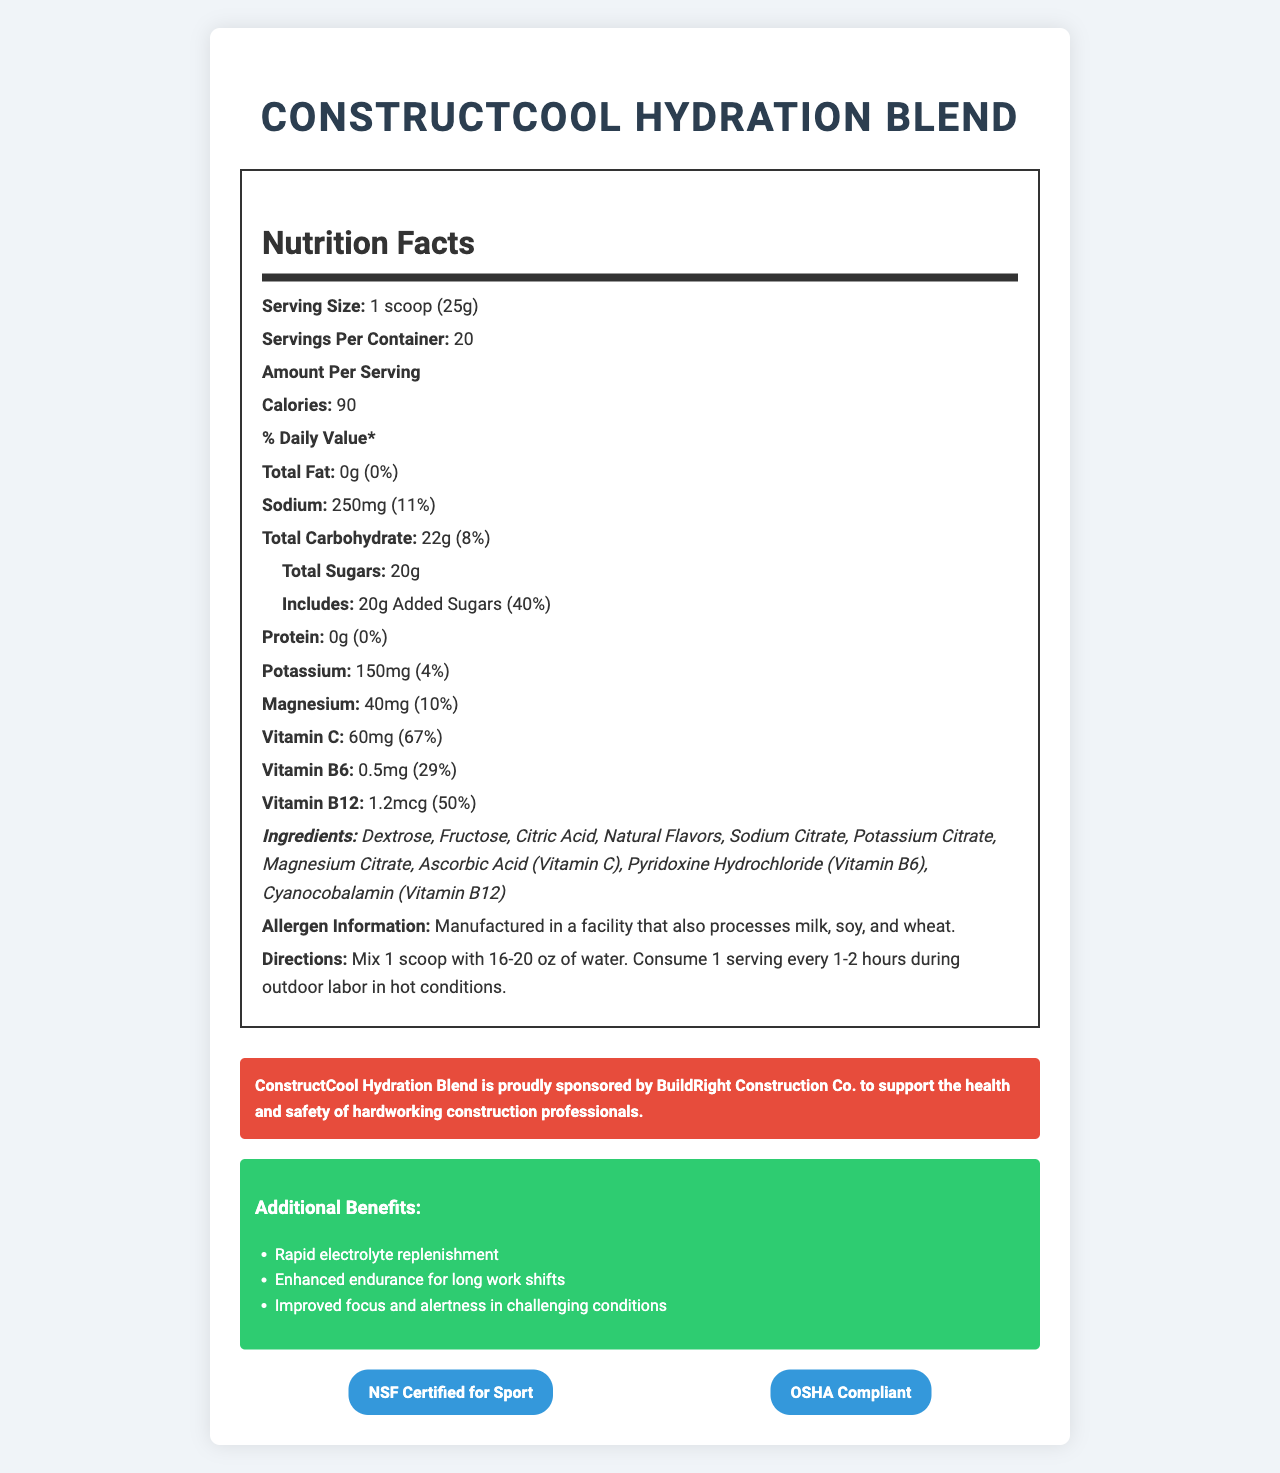what is the serving size? The serving size is clearly mentioned at the beginning of the Nutrition Facts section.
Answer: 1 scoop (25g) how many servings are in one container? The document specifies that there are 20 servings per container.
Answer: 20 how many calories are in one serving? The calorie count is listed under the "Amount Per Serving" section as 90 calories.
Answer: 90 how much sodium is in one serving? The amount of sodium per serving is specified as 250mg.
Answer: 250mg what percentage of the daily value of vitamin C does one serving provide? It is listed in the document under the "Amount Per Serving" section that 60mg of vitamin C provides 67% of the daily value.
Answer: 67% which vitamins are included in this hydration blend? A. Vitamin A, Vitamin C, Vitamin D B. Vitamin C, Vitamin B6, Vitamin B12 C. Vitamin D, Vitamin E, Vitamin K D. Vitamin B9, Vitamin B12, Vitamin C The document lists Vitamin C, Vitamin B6, and Vitamin B12 in the nutrition label.
Answer: B. Vitamin C, Vitamin B6, Vitamin B12 how many grams of total sugars does one serving contain? A. 10g B. 15g C. 20g D. 25g The document states that one serving contains 20 grams of total sugars.
Answer: C. 20g is the ConstructCool Hydration Blend allergen-free? The allergen information notes that it is manufactured in a facility that processes milk, soy, and wheat.
Answer: No what are the additional benefits of using ConstructCool Hydration Blend? The document lists these benefits in the "Additional Benefits" section.
Answer: Rapid electrolyte replenishment, Enhanced endurance for long work shifts, Improved focus and alertness in challenging conditions where is the ConstructCool Hydration Blend manufactured? The document does not provide any information about the manufacturing location.
Answer: Cannot be determined describe the main idea of the document The main idea revolves around describing the ConstructCool Hydration Blend's composition, nutritional content, benefits, and suitability for construction workers under hot conditions.
Answer: The document provides detailed nutrition facts, ingredients, allergens, directions, and additional benefits of the ConstructCool Hydration Blend. It highlights the hydration mix's suitability for outdoor labor in hot conditions, outlines its rapid electrolyte replenishment capabilities, and mentions company sponsorships and certifications. is the product NSF certified for sport? The document states that the product is NSF Certified for Sport.
Answer: Yes does one serving of ConstructCool Hydration Blend contain any protein? The nutrition label indicates that there is 0g of protein per serving.
Answer: No how much added sugars are there in one serving as a percentage of daily value? The document states that 20g of added sugars equates to 40% of the daily value.
Answer: 40% 